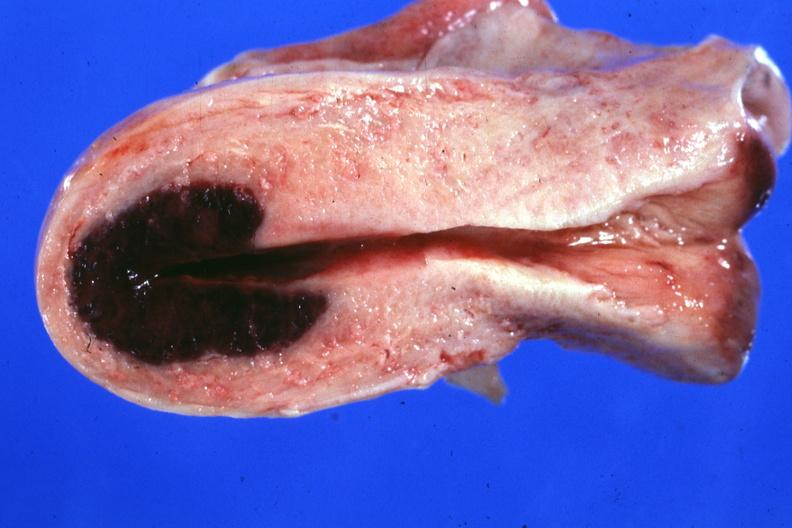where does this part belong to?
Answer the question using a single word or phrase. Female reproductive system 